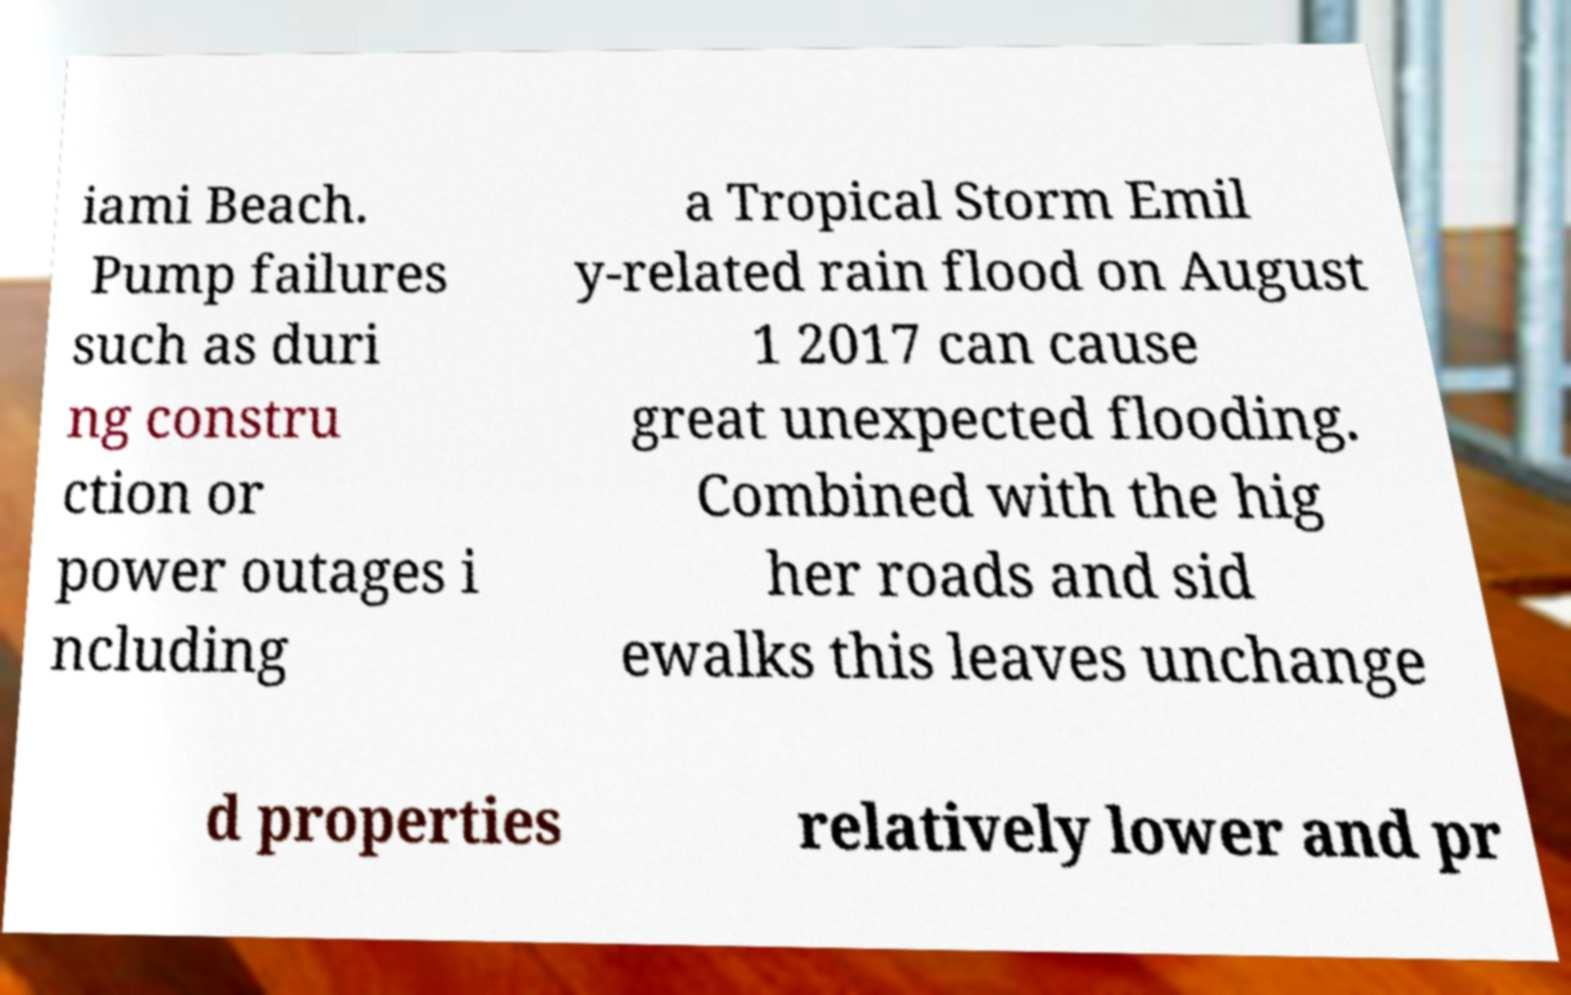Can you read and provide the text displayed in the image?This photo seems to have some interesting text. Can you extract and type it out for me? iami Beach. Pump failures such as duri ng constru ction or power outages i ncluding a Tropical Storm Emil y-related rain flood on August 1 2017 can cause great unexpected flooding. Combined with the hig her roads and sid ewalks this leaves unchange d properties relatively lower and pr 